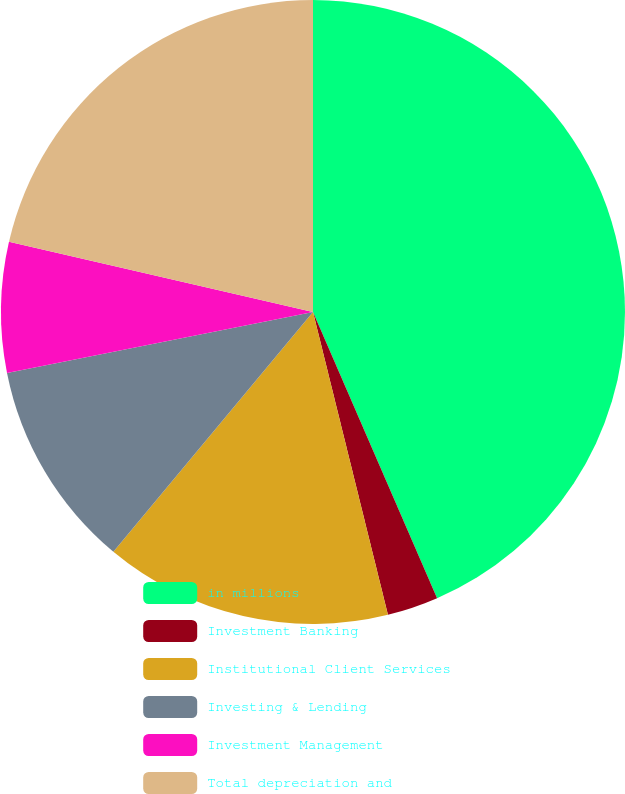Convert chart. <chart><loc_0><loc_0><loc_500><loc_500><pie_chart><fcel>in millions<fcel>Investment Banking<fcel>Institutional Client Services<fcel>Investing & Lending<fcel>Investment Management<fcel>Total depreciation and<nl><fcel>43.49%<fcel>2.65%<fcel>14.91%<fcel>10.82%<fcel>6.74%<fcel>21.39%<nl></chart> 